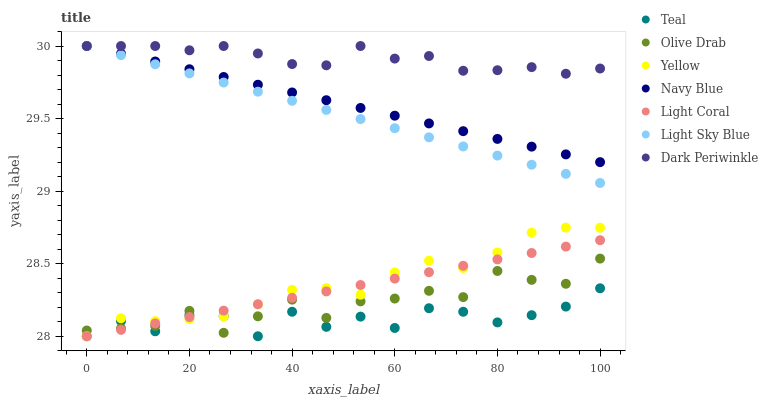Does Teal have the minimum area under the curve?
Answer yes or no. Yes. Does Dark Periwinkle have the maximum area under the curve?
Answer yes or no. Yes. Does Yellow have the minimum area under the curve?
Answer yes or no. No. Does Yellow have the maximum area under the curve?
Answer yes or no. No. Is Navy Blue the smoothest?
Answer yes or no. Yes. Is Teal the roughest?
Answer yes or no. Yes. Is Yellow the smoothest?
Answer yes or no. No. Is Yellow the roughest?
Answer yes or no. No. Does Yellow have the lowest value?
Answer yes or no. Yes. Does Light Sky Blue have the lowest value?
Answer yes or no. No. Does Dark Periwinkle have the highest value?
Answer yes or no. Yes. Does Yellow have the highest value?
Answer yes or no. No. Is Teal less than Navy Blue?
Answer yes or no. Yes. Is Light Sky Blue greater than Teal?
Answer yes or no. Yes. Does Navy Blue intersect Dark Periwinkle?
Answer yes or no. Yes. Is Navy Blue less than Dark Periwinkle?
Answer yes or no. No. Is Navy Blue greater than Dark Periwinkle?
Answer yes or no. No. Does Teal intersect Navy Blue?
Answer yes or no. No. 